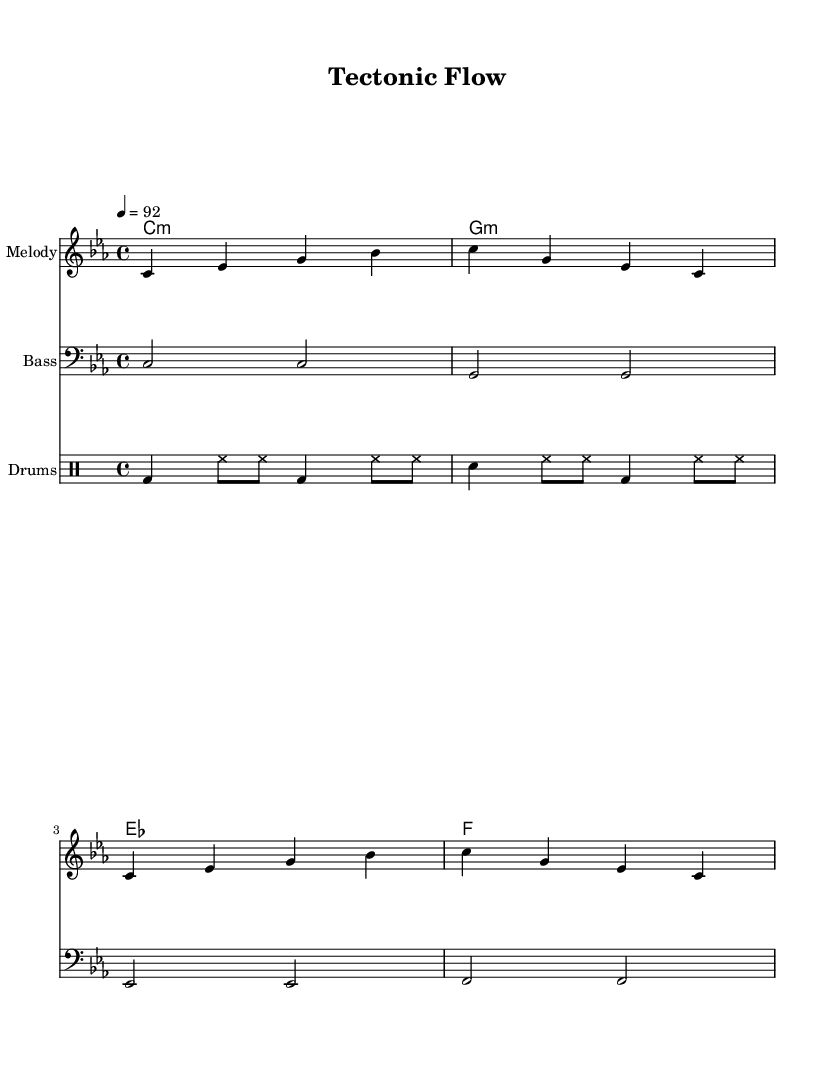What is the key signature of this music? The key signature is indicated at the beginning of the music, and it shows C minor, indicated by three flats.
Answer: C minor What is the time signature of this music? The time signature is located at the beginning right after the key signature, and it is 4/4, meaning there are four beats in each measure.
Answer: 4/4 What is the tempo marking for this piece? The tempo marking appears alongside the time signature, indicating the speed of the piece. It is set to 92 beats per minute.
Answer: 92 How many measures are in the melody section? By counting the individual bars in the melody line, we find that there are four measures in this section.
Answer: Four What theme is expressed in the lyrics of the verse? The lyrics reference studying geology with mentions of rocks, plates, and night labs, emphasizing the academic struggles faced by geology students.
Answer: Academic struggles What is the primary structure of the song? The song comprises verses and a chorus, which alternates throughout, characteristic of many rap songs, focusing on both narrative and catchiness.
Answer: Verses and chorus What do the drum patterns simulate in this rap piece? The drum patterns follow a conventional hip-hop beat, with the bass drum and snare defining the rhythm, typical in creating a strong foundation in rap tracks.
Answer: Conventional hip-hop beat 